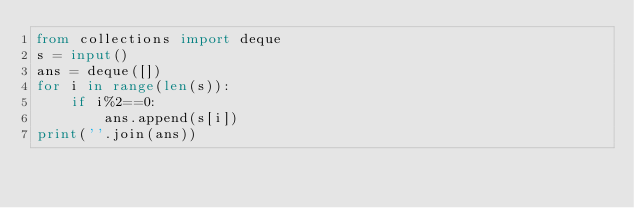Convert code to text. <code><loc_0><loc_0><loc_500><loc_500><_Python_>from collections import deque
s = input()
ans = deque([])
for i in range(len(s)):
    if i%2==0:
        ans.append(s[i])
print(''.join(ans))
</code> 